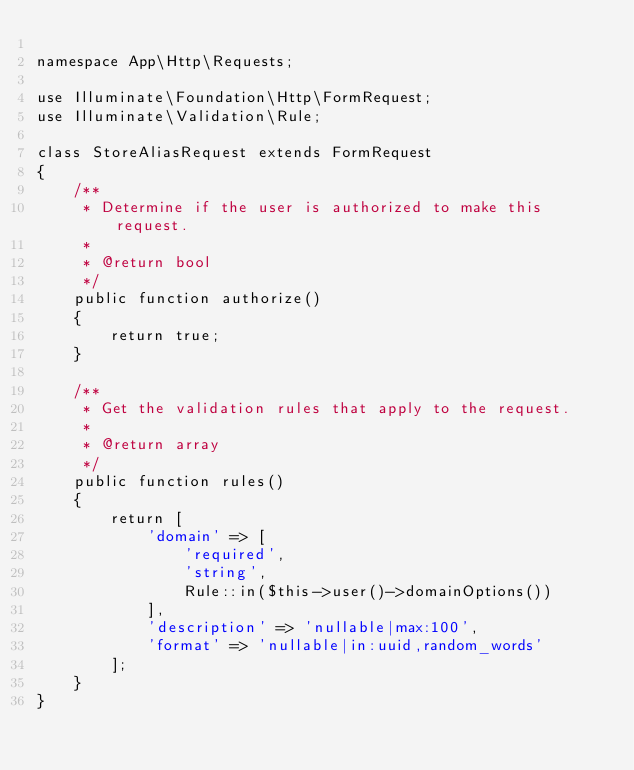Convert code to text. <code><loc_0><loc_0><loc_500><loc_500><_PHP_>
namespace App\Http\Requests;

use Illuminate\Foundation\Http\FormRequest;
use Illuminate\Validation\Rule;

class StoreAliasRequest extends FormRequest
{
    /**
     * Determine if the user is authorized to make this request.
     *
     * @return bool
     */
    public function authorize()
    {
        return true;
    }

    /**
     * Get the validation rules that apply to the request.
     *
     * @return array
     */
    public function rules()
    {
        return [
            'domain' => [
                'required',
                'string',
                Rule::in($this->user()->domainOptions())
            ],
            'description' => 'nullable|max:100',
            'format' => 'nullable|in:uuid,random_words'
        ];
    }
}
</code> 